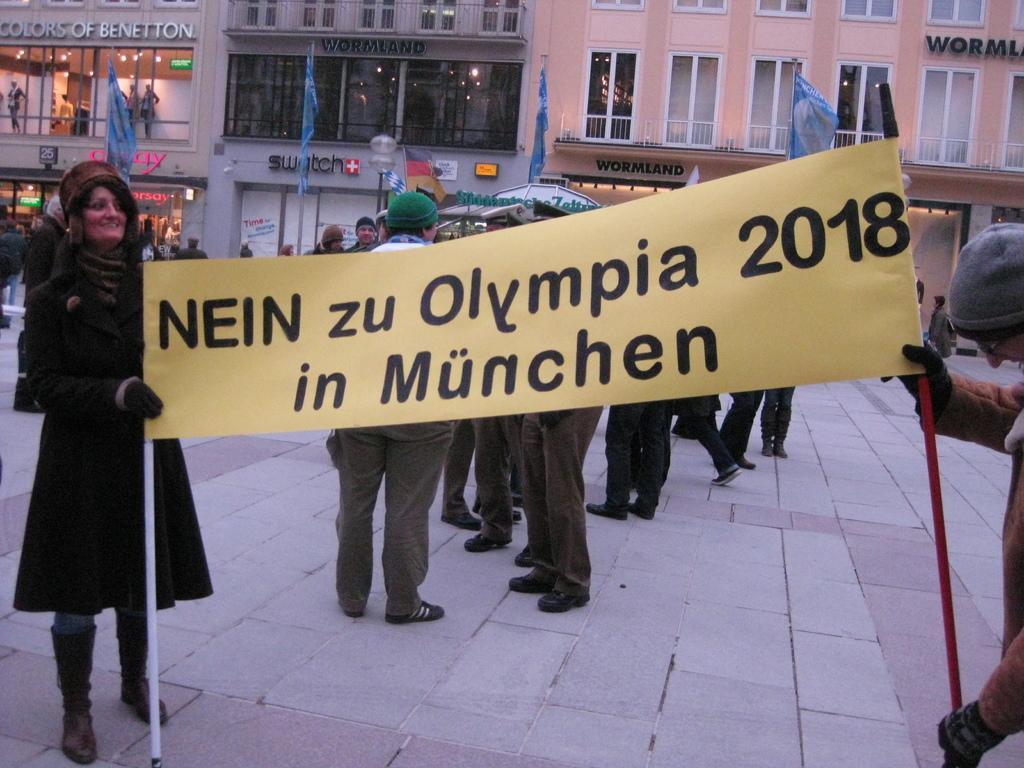Please provide a concise description of this image. As we can see in the image there is a banner, few people here and there, buildings and fence. 